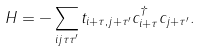<formula> <loc_0><loc_0><loc_500><loc_500>H = - \sum _ { i j \tau \tau ^ { \prime } } t _ { i + \tau , j + \tau ^ { \prime } } c ^ { \dag } _ { i + \tau } c _ { j + \tau ^ { \prime } } .</formula> 